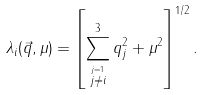<formula> <loc_0><loc_0><loc_500><loc_500>\lambda _ { i } ( \vec { q } , \mu ) = { \left [ \sum ^ { 3 } _ { \stackrel { j = 1 } { j \neq i } } q ^ { 2 } _ { j } + \mu ^ { 2 } \right ] } ^ { { 1 } / { 2 } } \, .</formula> 